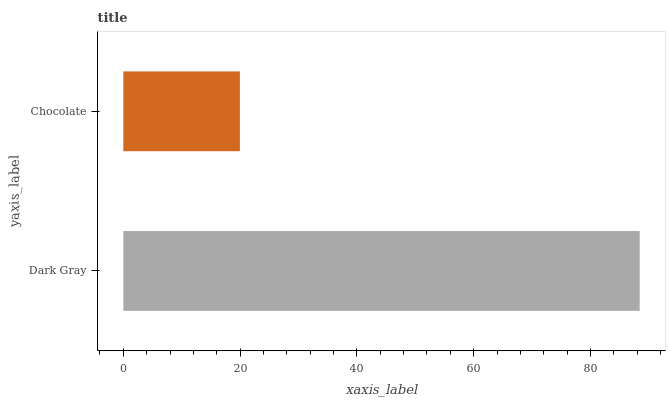Is Chocolate the minimum?
Answer yes or no. Yes. Is Dark Gray the maximum?
Answer yes or no. Yes. Is Chocolate the maximum?
Answer yes or no. No. Is Dark Gray greater than Chocolate?
Answer yes or no. Yes. Is Chocolate less than Dark Gray?
Answer yes or no. Yes. Is Chocolate greater than Dark Gray?
Answer yes or no. No. Is Dark Gray less than Chocolate?
Answer yes or no. No. Is Dark Gray the high median?
Answer yes or no. Yes. Is Chocolate the low median?
Answer yes or no. Yes. Is Chocolate the high median?
Answer yes or no. No. Is Dark Gray the low median?
Answer yes or no. No. 